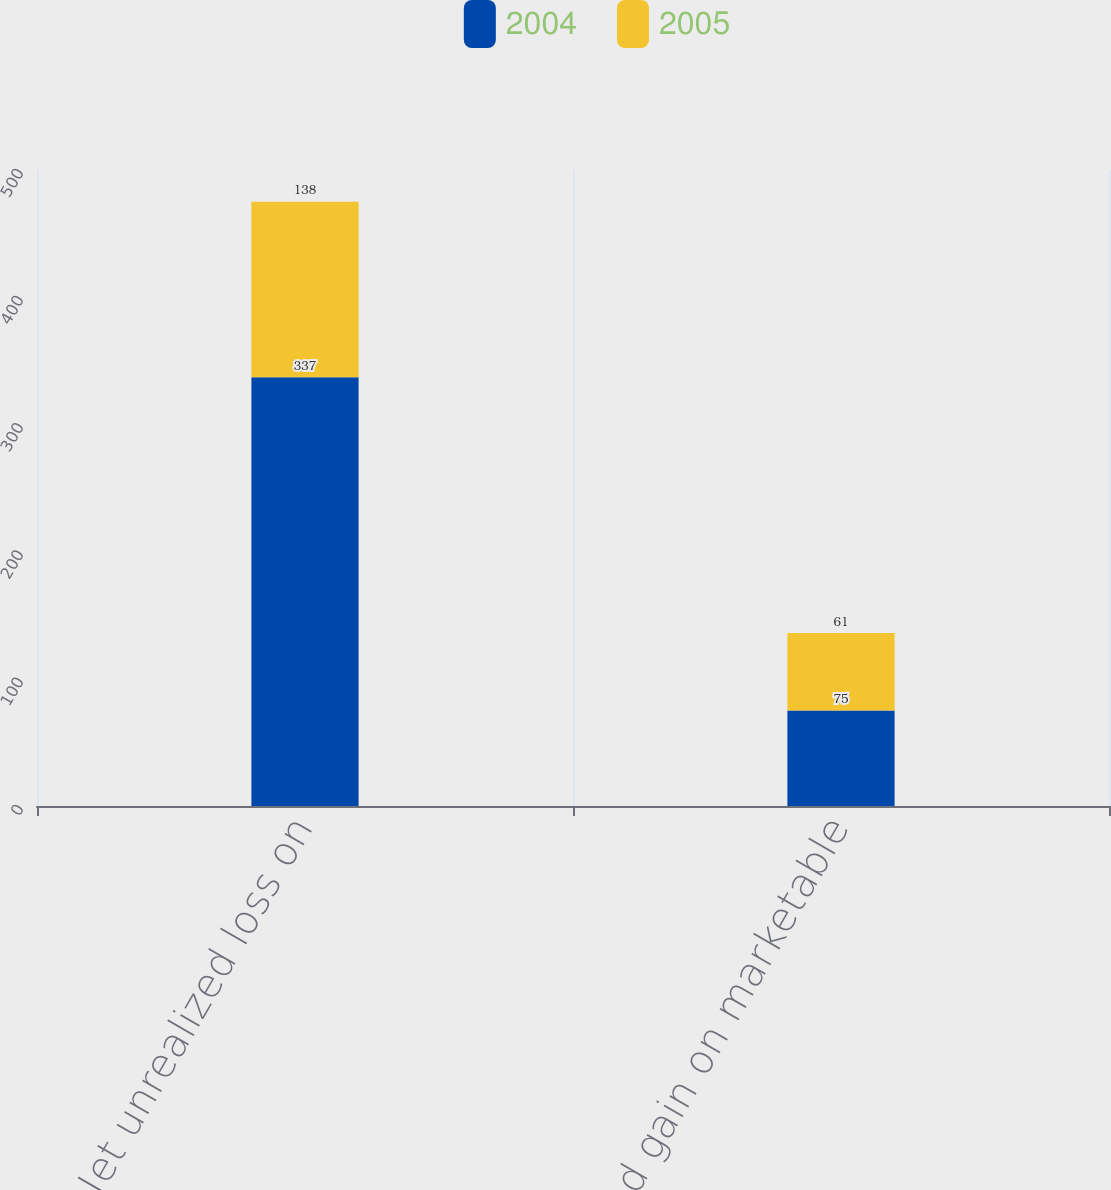Convert chart. <chart><loc_0><loc_0><loc_500><loc_500><stacked_bar_chart><ecel><fcel>Net unrealized loss on<fcel>Unrealized gain on marketable<nl><fcel>2004<fcel>337<fcel>75<nl><fcel>2005<fcel>138<fcel>61<nl></chart> 